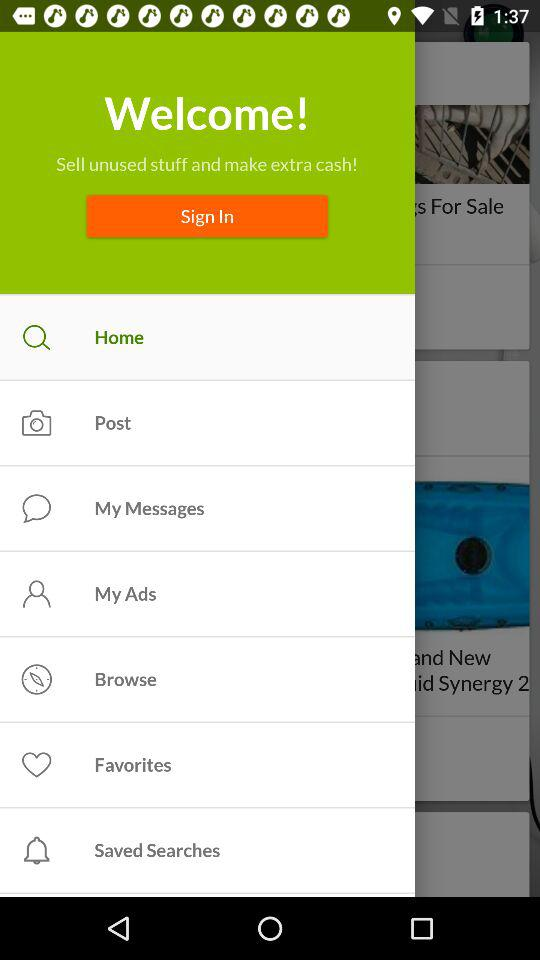Which option is selected? The selected option is "Home". 